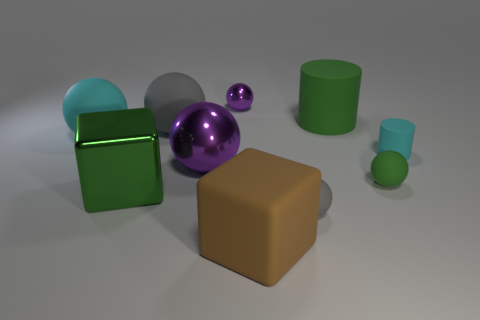Subtract 3 balls. How many balls are left? 3 Subtract all tiny rubber balls. How many balls are left? 4 Subtract all cyan balls. How many balls are left? 5 Subtract all brown spheres. Subtract all blue cylinders. How many spheres are left? 6 Subtract all spheres. How many objects are left? 4 Add 6 blue rubber blocks. How many blue rubber blocks exist? 6 Subtract 0 blue blocks. How many objects are left? 10 Subtract all tiny cyan rubber cylinders. Subtract all small cyan objects. How many objects are left? 8 Add 2 cyan matte objects. How many cyan matte objects are left? 4 